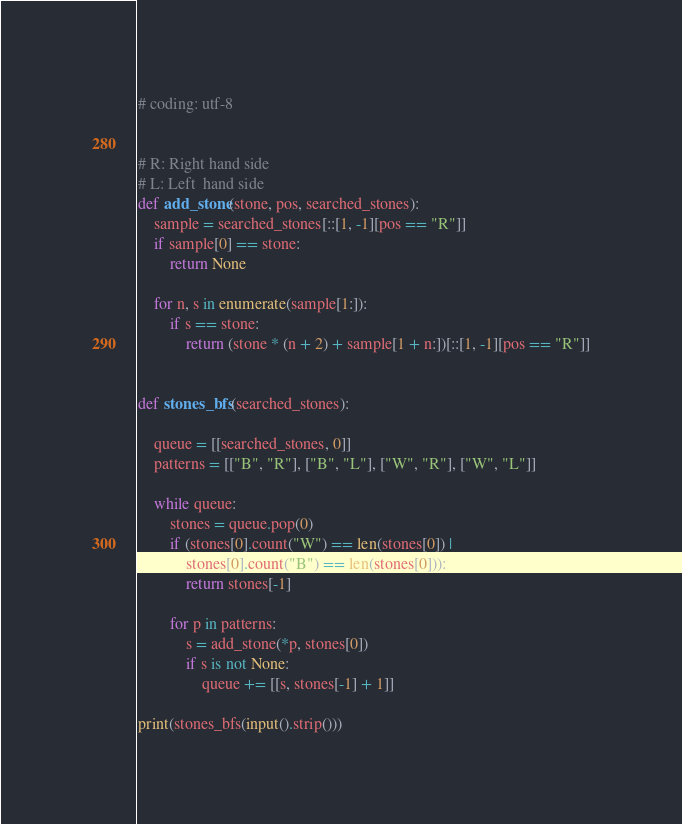Convert code to text. <code><loc_0><loc_0><loc_500><loc_500><_Python_># coding: utf-8


# R: Right hand side
# L: Left  hand side
def add_stone(stone, pos, searched_stones):
    sample = searched_stones[::[1, -1][pos == "R"]]
    if sample[0] == stone:
        return None

    for n, s in enumerate(sample[1:]):
        if s == stone:
            return (stone * (n + 2) + sample[1 + n:])[::[1, -1][pos == "R"]]


def stones_bfs(searched_stones):
    
    queue = [[searched_stones, 0]]
    patterns = [["B", "R"], ["B", "L"], ["W", "R"], ["W", "L"]]
    
    while queue:
        stones = queue.pop(0)
        if (stones[0].count("W") == len(stones[0]) |
            stones[0].count("B") == len(stones[0])):
            return stones[-1]
            
        for p in patterns:
            s = add_stone(*p, stones[0])
            if s is not None:
                queue += [[s, stones[-1] + 1]]

print(stones_bfs(input().strip()))</code> 